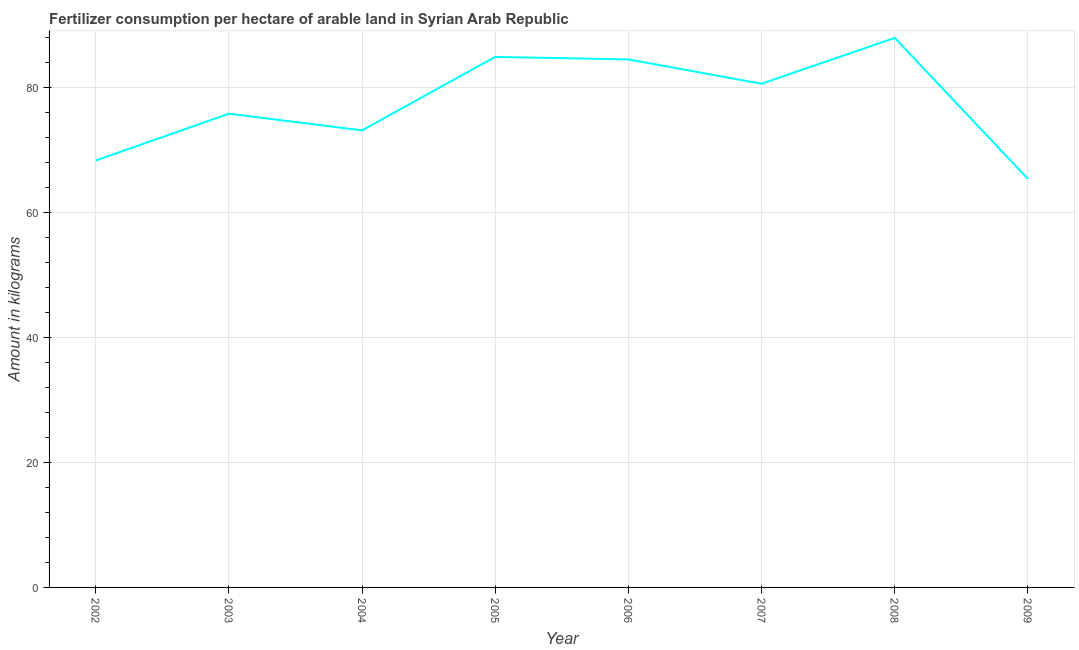What is the amount of fertilizer consumption in 2002?
Make the answer very short. 68.35. Across all years, what is the maximum amount of fertilizer consumption?
Offer a terse response. 87.99. Across all years, what is the minimum amount of fertilizer consumption?
Provide a short and direct response. 65.42. In which year was the amount of fertilizer consumption minimum?
Provide a succinct answer. 2009. What is the sum of the amount of fertilizer consumption?
Offer a terse response. 620.93. What is the difference between the amount of fertilizer consumption in 2003 and 2006?
Offer a very short reply. -8.69. What is the average amount of fertilizer consumption per year?
Your answer should be very brief. 77.62. What is the median amount of fertilizer consumption?
Ensure brevity in your answer.  78.25. What is the ratio of the amount of fertilizer consumption in 2004 to that in 2005?
Make the answer very short. 0.86. What is the difference between the highest and the second highest amount of fertilizer consumption?
Keep it short and to the point. 3.04. Is the sum of the amount of fertilizer consumption in 2002 and 2007 greater than the maximum amount of fertilizer consumption across all years?
Your answer should be compact. Yes. What is the difference between the highest and the lowest amount of fertilizer consumption?
Offer a very short reply. 22.57. In how many years, is the amount of fertilizer consumption greater than the average amount of fertilizer consumption taken over all years?
Provide a succinct answer. 4. How many lines are there?
Provide a short and direct response. 1. How many years are there in the graph?
Provide a succinct answer. 8. What is the difference between two consecutive major ticks on the Y-axis?
Your response must be concise. 20. Are the values on the major ticks of Y-axis written in scientific E-notation?
Your answer should be very brief. No. Does the graph contain any zero values?
Keep it short and to the point. No. Does the graph contain grids?
Your answer should be compact. Yes. What is the title of the graph?
Ensure brevity in your answer.  Fertilizer consumption per hectare of arable land in Syrian Arab Republic . What is the label or title of the X-axis?
Provide a short and direct response. Year. What is the label or title of the Y-axis?
Your response must be concise. Amount in kilograms. What is the Amount in kilograms of 2002?
Your response must be concise. 68.35. What is the Amount in kilograms of 2003?
Provide a short and direct response. 75.85. What is the Amount in kilograms in 2004?
Your answer should be very brief. 73.18. What is the Amount in kilograms in 2005?
Your answer should be compact. 84.95. What is the Amount in kilograms in 2006?
Ensure brevity in your answer.  84.54. What is the Amount in kilograms of 2007?
Provide a succinct answer. 80.65. What is the Amount in kilograms in 2008?
Your answer should be compact. 87.99. What is the Amount in kilograms in 2009?
Your answer should be compact. 65.42. What is the difference between the Amount in kilograms in 2002 and 2003?
Your answer should be compact. -7.5. What is the difference between the Amount in kilograms in 2002 and 2004?
Your answer should be compact. -4.83. What is the difference between the Amount in kilograms in 2002 and 2005?
Offer a very short reply. -16.59. What is the difference between the Amount in kilograms in 2002 and 2006?
Provide a short and direct response. -16.19. What is the difference between the Amount in kilograms in 2002 and 2007?
Your response must be concise. -12.29. What is the difference between the Amount in kilograms in 2002 and 2008?
Offer a very short reply. -19.64. What is the difference between the Amount in kilograms in 2002 and 2009?
Offer a terse response. 2.93. What is the difference between the Amount in kilograms in 2003 and 2004?
Offer a very short reply. 2.67. What is the difference between the Amount in kilograms in 2003 and 2005?
Your response must be concise. -9.1. What is the difference between the Amount in kilograms in 2003 and 2006?
Offer a very short reply. -8.69. What is the difference between the Amount in kilograms in 2003 and 2007?
Your answer should be very brief. -4.8. What is the difference between the Amount in kilograms in 2003 and 2008?
Ensure brevity in your answer.  -12.14. What is the difference between the Amount in kilograms in 2003 and 2009?
Give a very brief answer. 10.43. What is the difference between the Amount in kilograms in 2004 and 2005?
Offer a terse response. -11.76. What is the difference between the Amount in kilograms in 2004 and 2006?
Your answer should be compact. -11.36. What is the difference between the Amount in kilograms in 2004 and 2007?
Provide a short and direct response. -7.46. What is the difference between the Amount in kilograms in 2004 and 2008?
Your answer should be very brief. -14.81. What is the difference between the Amount in kilograms in 2004 and 2009?
Provide a short and direct response. 7.76. What is the difference between the Amount in kilograms in 2005 and 2006?
Keep it short and to the point. 0.4. What is the difference between the Amount in kilograms in 2005 and 2007?
Provide a short and direct response. 4.3. What is the difference between the Amount in kilograms in 2005 and 2008?
Provide a succinct answer. -3.04. What is the difference between the Amount in kilograms in 2005 and 2009?
Your response must be concise. 19.52. What is the difference between the Amount in kilograms in 2006 and 2007?
Make the answer very short. 3.9. What is the difference between the Amount in kilograms in 2006 and 2008?
Your answer should be very brief. -3.45. What is the difference between the Amount in kilograms in 2006 and 2009?
Provide a succinct answer. 19.12. What is the difference between the Amount in kilograms in 2007 and 2008?
Provide a succinct answer. -7.34. What is the difference between the Amount in kilograms in 2007 and 2009?
Make the answer very short. 15.22. What is the difference between the Amount in kilograms in 2008 and 2009?
Your answer should be very brief. 22.57. What is the ratio of the Amount in kilograms in 2002 to that in 2003?
Offer a very short reply. 0.9. What is the ratio of the Amount in kilograms in 2002 to that in 2004?
Offer a terse response. 0.93. What is the ratio of the Amount in kilograms in 2002 to that in 2005?
Make the answer very short. 0.81. What is the ratio of the Amount in kilograms in 2002 to that in 2006?
Provide a succinct answer. 0.81. What is the ratio of the Amount in kilograms in 2002 to that in 2007?
Your answer should be compact. 0.85. What is the ratio of the Amount in kilograms in 2002 to that in 2008?
Offer a terse response. 0.78. What is the ratio of the Amount in kilograms in 2002 to that in 2009?
Offer a very short reply. 1.04. What is the ratio of the Amount in kilograms in 2003 to that in 2004?
Provide a succinct answer. 1.04. What is the ratio of the Amount in kilograms in 2003 to that in 2005?
Your answer should be very brief. 0.89. What is the ratio of the Amount in kilograms in 2003 to that in 2006?
Your answer should be very brief. 0.9. What is the ratio of the Amount in kilograms in 2003 to that in 2007?
Provide a short and direct response. 0.94. What is the ratio of the Amount in kilograms in 2003 to that in 2008?
Provide a short and direct response. 0.86. What is the ratio of the Amount in kilograms in 2003 to that in 2009?
Make the answer very short. 1.16. What is the ratio of the Amount in kilograms in 2004 to that in 2005?
Your answer should be very brief. 0.86. What is the ratio of the Amount in kilograms in 2004 to that in 2006?
Provide a short and direct response. 0.87. What is the ratio of the Amount in kilograms in 2004 to that in 2007?
Keep it short and to the point. 0.91. What is the ratio of the Amount in kilograms in 2004 to that in 2008?
Make the answer very short. 0.83. What is the ratio of the Amount in kilograms in 2004 to that in 2009?
Make the answer very short. 1.12. What is the ratio of the Amount in kilograms in 2005 to that in 2007?
Give a very brief answer. 1.05. What is the ratio of the Amount in kilograms in 2005 to that in 2009?
Give a very brief answer. 1.3. What is the ratio of the Amount in kilograms in 2006 to that in 2007?
Offer a very short reply. 1.05. What is the ratio of the Amount in kilograms in 2006 to that in 2008?
Offer a terse response. 0.96. What is the ratio of the Amount in kilograms in 2006 to that in 2009?
Ensure brevity in your answer.  1.29. What is the ratio of the Amount in kilograms in 2007 to that in 2008?
Ensure brevity in your answer.  0.92. What is the ratio of the Amount in kilograms in 2007 to that in 2009?
Give a very brief answer. 1.23. What is the ratio of the Amount in kilograms in 2008 to that in 2009?
Keep it short and to the point. 1.34. 